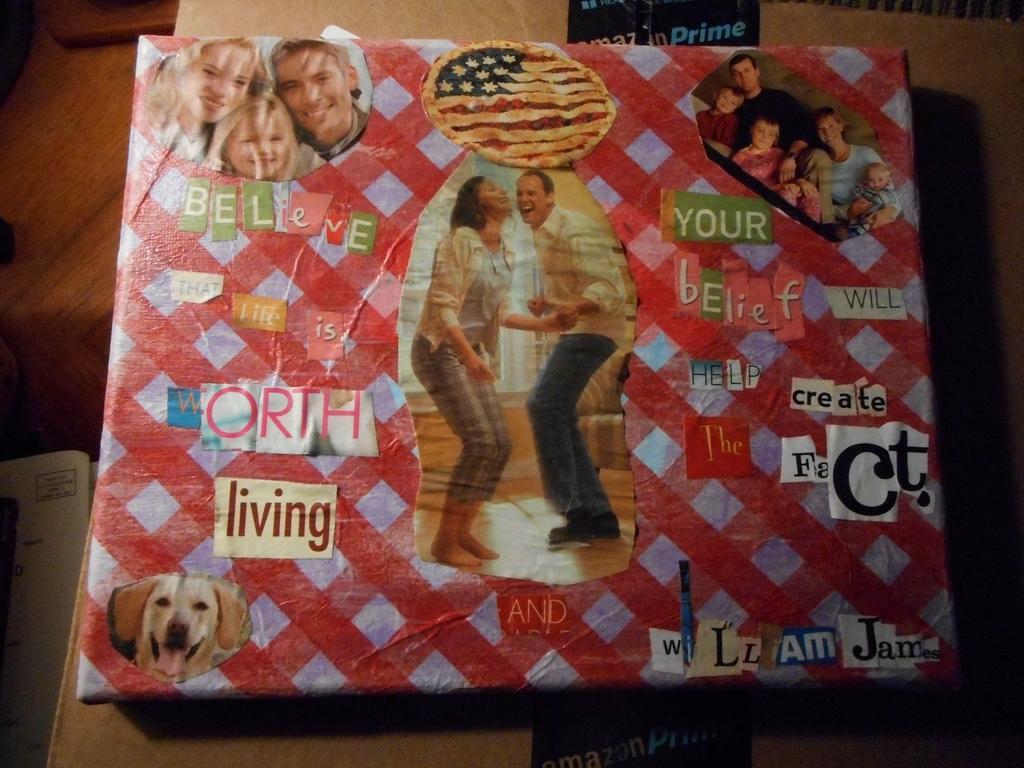In one or two sentences, can you explain what this image depicts? In this image there is a gift cover pack as we can see in middle of this image. There is a picture of dog at left side of this image and there is a photo of two persons standing in middle of this image and there are some persons at top right corner of this image. 